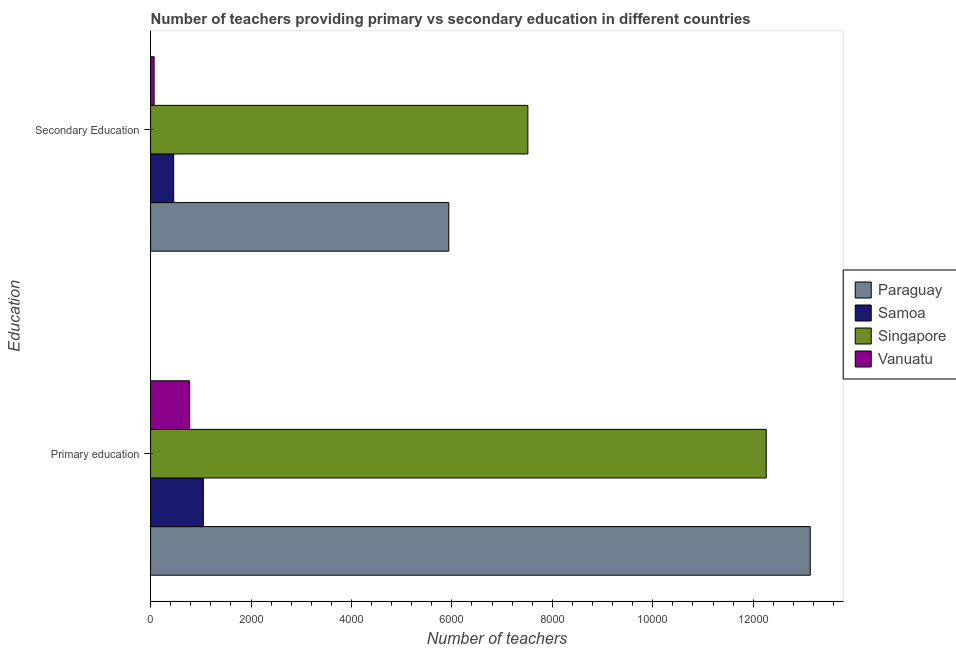Are the number of bars per tick equal to the number of legend labels?
Give a very brief answer. Yes. How many bars are there on the 2nd tick from the bottom?
Offer a very short reply. 4. What is the label of the 1st group of bars from the top?
Provide a short and direct response. Secondary Education. What is the number of primary teachers in Samoa?
Provide a succinct answer. 1051. Across all countries, what is the maximum number of primary teachers?
Give a very brief answer. 1.31e+04. Across all countries, what is the minimum number of primary teachers?
Provide a succinct answer. 778. In which country was the number of primary teachers maximum?
Your answer should be compact. Paraguay. In which country was the number of primary teachers minimum?
Your answer should be very brief. Vanuatu. What is the total number of secondary teachers in the graph?
Offer a terse response. 1.40e+04. What is the difference between the number of secondary teachers in Samoa and that in Vanuatu?
Ensure brevity in your answer.  389. What is the difference between the number of secondary teachers in Samoa and the number of primary teachers in Paraguay?
Offer a terse response. -1.27e+04. What is the average number of secondary teachers per country?
Offer a terse response. 3495.5. What is the difference between the number of primary teachers and number of secondary teachers in Paraguay?
Make the answer very short. 7197. What is the ratio of the number of secondary teachers in Samoa to that in Vanuatu?
Your answer should be compact. 6.48. Is the number of secondary teachers in Singapore less than that in Vanuatu?
Provide a short and direct response. No. What does the 3rd bar from the top in Secondary Education represents?
Your response must be concise. Samoa. What does the 4th bar from the bottom in Primary education represents?
Your answer should be very brief. Vanuatu. How many bars are there?
Provide a succinct answer. 8. Are all the bars in the graph horizontal?
Your answer should be very brief. Yes. How many countries are there in the graph?
Give a very brief answer. 4. Are the values on the major ticks of X-axis written in scientific E-notation?
Offer a very short reply. No. Does the graph contain grids?
Your response must be concise. No. Where does the legend appear in the graph?
Offer a very short reply. Center right. How many legend labels are there?
Ensure brevity in your answer.  4. What is the title of the graph?
Ensure brevity in your answer.  Number of teachers providing primary vs secondary education in different countries. What is the label or title of the X-axis?
Your answer should be very brief. Number of teachers. What is the label or title of the Y-axis?
Ensure brevity in your answer.  Education. What is the Number of teachers in Paraguay in Primary education?
Your answer should be very brief. 1.31e+04. What is the Number of teachers of Samoa in Primary education?
Make the answer very short. 1051. What is the Number of teachers of Singapore in Primary education?
Your response must be concise. 1.23e+04. What is the Number of teachers of Vanuatu in Primary education?
Your answer should be very brief. 778. What is the Number of teachers in Paraguay in Secondary Education?
Your response must be concise. 5938. What is the Number of teachers of Samoa in Secondary Education?
Provide a short and direct response. 460. What is the Number of teachers of Singapore in Secondary Education?
Keep it short and to the point. 7513. What is the Number of teachers in Vanuatu in Secondary Education?
Your response must be concise. 71. Across all Education, what is the maximum Number of teachers in Paraguay?
Provide a succinct answer. 1.31e+04. Across all Education, what is the maximum Number of teachers in Samoa?
Provide a succinct answer. 1051. Across all Education, what is the maximum Number of teachers of Singapore?
Ensure brevity in your answer.  1.23e+04. Across all Education, what is the maximum Number of teachers of Vanuatu?
Ensure brevity in your answer.  778. Across all Education, what is the minimum Number of teachers in Paraguay?
Your answer should be very brief. 5938. Across all Education, what is the minimum Number of teachers in Samoa?
Provide a succinct answer. 460. Across all Education, what is the minimum Number of teachers in Singapore?
Your answer should be very brief. 7513. What is the total Number of teachers in Paraguay in the graph?
Offer a very short reply. 1.91e+04. What is the total Number of teachers in Samoa in the graph?
Provide a succinct answer. 1511. What is the total Number of teachers of Singapore in the graph?
Provide a short and direct response. 1.98e+04. What is the total Number of teachers of Vanuatu in the graph?
Offer a very short reply. 849. What is the difference between the Number of teachers in Paraguay in Primary education and that in Secondary Education?
Offer a terse response. 7197. What is the difference between the Number of teachers of Samoa in Primary education and that in Secondary Education?
Your response must be concise. 591. What is the difference between the Number of teachers of Singapore in Primary education and that in Secondary Education?
Give a very brief answer. 4746. What is the difference between the Number of teachers in Vanuatu in Primary education and that in Secondary Education?
Keep it short and to the point. 707. What is the difference between the Number of teachers of Paraguay in Primary education and the Number of teachers of Samoa in Secondary Education?
Ensure brevity in your answer.  1.27e+04. What is the difference between the Number of teachers in Paraguay in Primary education and the Number of teachers in Singapore in Secondary Education?
Keep it short and to the point. 5622. What is the difference between the Number of teachers of Paraguay in Primary education and the Number of teachers of Vanuatu in Secondary Education?
Your response must be concise. 1.31e+04. What is the difference between the Number of teachers in Samoa in Primary education and the Number of teachers in Singapore in Secondary Education?
Your answer should be compact. -6462. What is the difference between the Number of teachers in Samoa in Primary education and the Number of teachers in Vanuatu in Secondary Education?
Your answer should be compact. 980. What is the difference between the Number of teachers of Singapore in Primary education and the Number of teachers of Vanuatu in Secondary Education?
Your answer should be compact. 1.22e+04. What is the average Number of teachers in Paraguay per Education?
Provide a succinct answer. 9536.5. What is the average Number of teachers of Samoa per Education?
Provide a short and direct response. 755.5. What is the average Number of teachers of Singapore per Education?
Keep it short and to the point. 9886. What is the average Number of teachers of Vanuatu per Education?
Offer a very short reply. 424.5. What is the difference between the Number of teachers in Paraguay and Number of teachers in Samoa in Primary education?
Ensure brevity in your answer.  1.21e+04. What is the difference between the Number of teachers in Paraguay and Number of teachers in Singapore in Primary education?
Your response must be concise. 876. What is the difference between the Number of teachers in Paraguay and Number of teachers in Vanuatu in Primary education?
Make the answer very short. 1.24e+04. What is the difference between the Number of teachers of Samoa and Number of teachers of Singapore in Primary education?
Offer a terse response. -1.12e+04. What is the difference between the Number of teachers of Samoa and Number of teachers of Vanuatu in Primary education?
Your answer should be very brief. 273. What is the difference between the Number of teachers of Singapore and Number of teachers of Vanuatu in Primary education?
Ensure brevity in your answer.  1.15e+04. What is the difference between the Number of teachers in Paraguay and Number of teachers in Samoa in Secondary Education?
Keep it short and to the point. 5478. What is the difference between the Number of teachers in Paraguay and Number of teachers in Singapore in Secondary Education?
Give a very brief answer. -1575. What is the difference between the Number of teachers of Paraguay and Number of teachers of Vanuatu in Secondary Education?
Make the answer very short. 5867. What is the difference between the Number of teachers in Samoa and Number of teachers in Singapore in Secondary Education?
Provide a short and direct response. -7053. What is the difference between the Number of teachers of Samoa and Number of teachers of Vanuatu in Secondary Education?
Ensure brevity in your answer.  389. What is the difference between the Number of teachers of Singapore and Number of teachers of Vanuatu in Secondary Education?
Keep it short and to the point. 7442. What is the ratio of the Number of teachers in Paraguay in Primary education to that in Secondary Education?
Ensure brevity in your answer.  2.21. What is the ratio of the Number of teachers in Samoa in Primary education to that in Secondary Education?
Keep it short and to the point. 2.28. What is the ratio of the Number of teachers in Singapore in Primary education to that in Secondary Education?
Keep it short and to the point. 1.63. What is the ratio of the Number of teachers in Vanuatu in Primary education to that in Secondary Education?
Provide a succinct answer. 10.96. What is the difference between the highest and the second highest Number of teachers of Paraguay?
Offer a terse response. 7197. What is the difference between the highest and the second highest Number of teachers of Samoa?
Make the answer very short. 591. What is the difference between the highest and the second highest Number of teachers in Singapore?
Your answer should be very brief. 4746. What is the difference between the highest and the second highest Number of teachers of Vanuatu?
Ensure brevity in your answer.  707. What is the difference between the highest and the lowest Number of teachers in Paraguay?
Your response must be concise. 7197. What is the difference between the highest and the lowest Number of teachers of Samoa?
Offer a terse response. 591. What is the difference between the highest and the lowest Number of teachers in Singapore?
Provide a short and direct response. 4746. What is the difference between the highest and the lowest Number of teachers of Vanuatu?
Ensure brevity in your answer.  707. 